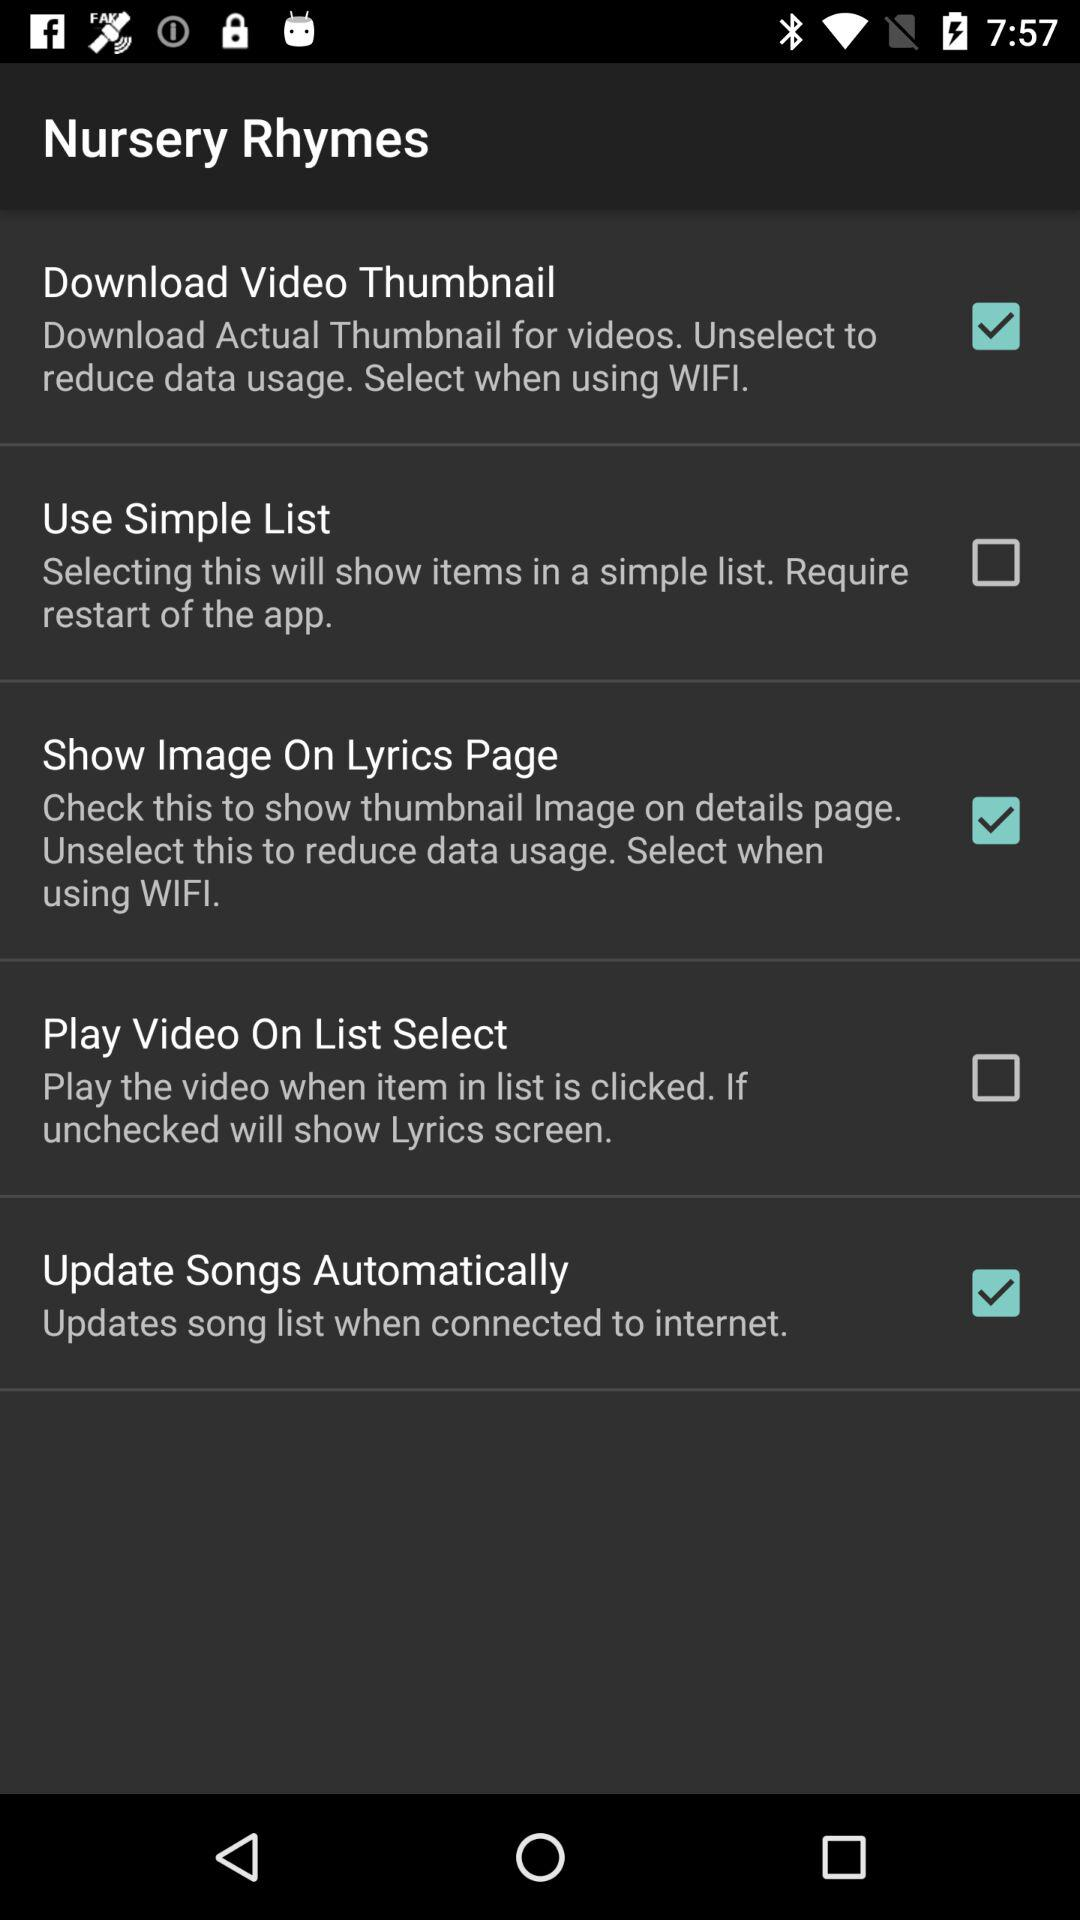How many checkboxes are present?
Answer the question using a single word or phrase. 5 